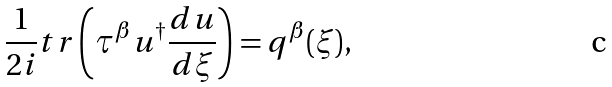<formula> <loc_0><loc_0><loc_500><loc_500>\frac { 1 } { 2 i } t r \left ( \tau ^ { \beta } u ^ { \dagger } \frac { d u } { d \xi } \right ) = q ^ { \beta } ( \xi ) ,</formula> 